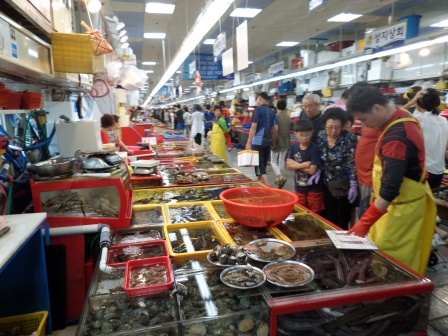Imagine a magical scenario occurring at this market. In a whimsical twist of events, imagine that one day, as the market bustles with its usual activity, a shimmering light envelops the largest tank. To everyone's astonishment, the seafood within begins to glow, and out of the water emerges a mystical mermaid. She holds aloft a golden seashell, which she explains has the power to unite the market with the ocean, creating an endless supply of the freshest seafood without ever harming the marine ecosystem. The mermaid, with her melodic voice, tells tales of underwater kingdoms and shares secrets of seafood cuisine that amaze both vendors and customers alike. The market transforms into a magical hub where land meets the sea, fostering an enchanting partnership that benefits both humans and marine life.  Describe a typical day at this seafood market in winter. A typical winter day at the seafood market is slightly different from the warmer months. Customers, bundled in warm coats and scarves, hustle inside to escape the chilly air. Despite the cold outside, the market retains its warm and lively atmosphere. The tanks continue to teem with fresh seafood, albeit with a more seasonal selection. Vendors might offer special winter delicacies such as sea bass or crabs that are in peak season. The warmth from the lights and the friendly interactions provide a cozy comfort against the winter chill, making a visit to the market a delightful experience even in the colder months. 